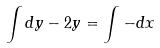<formula> <loc_0><loc_0><loc_500><loc_500>\int d y - 2 y = \int - d x</formula> 